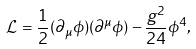Convert formula to latex. <formula><loc_0><loc_0><loc_500><loc_500>\mathcal { L } = \frac { 1 } { 2 } ( \partial _ { \mu } \phi ) ( \partial ^ { \mu } \phi ) - \frac { g ^ { 2 } } { 2 4 } \phi ^ { 4 } ,</formula> 